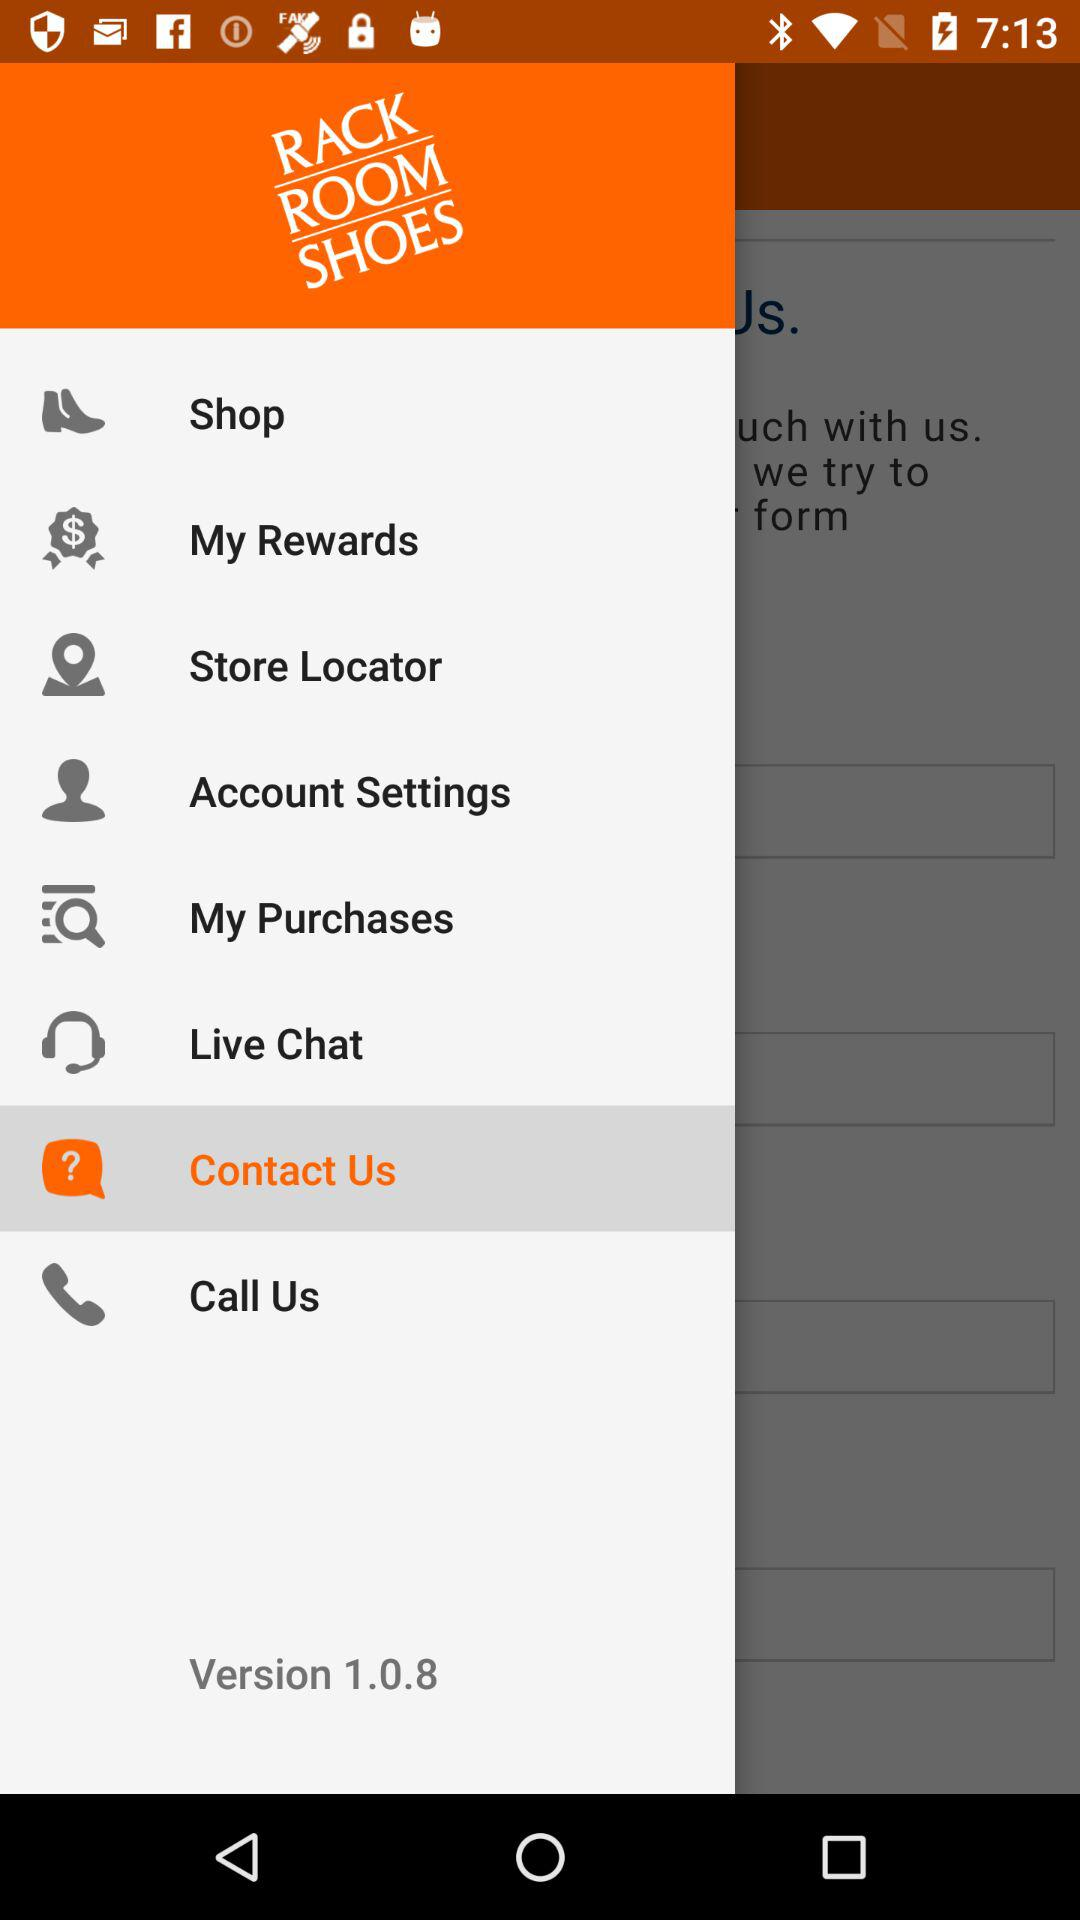What option is selected? The selected option is Contact Us. 